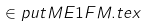<formula> <loc_0><loc_0><loc_500><loc_500>\in p u t M E 1 F M . t e x</formula> 